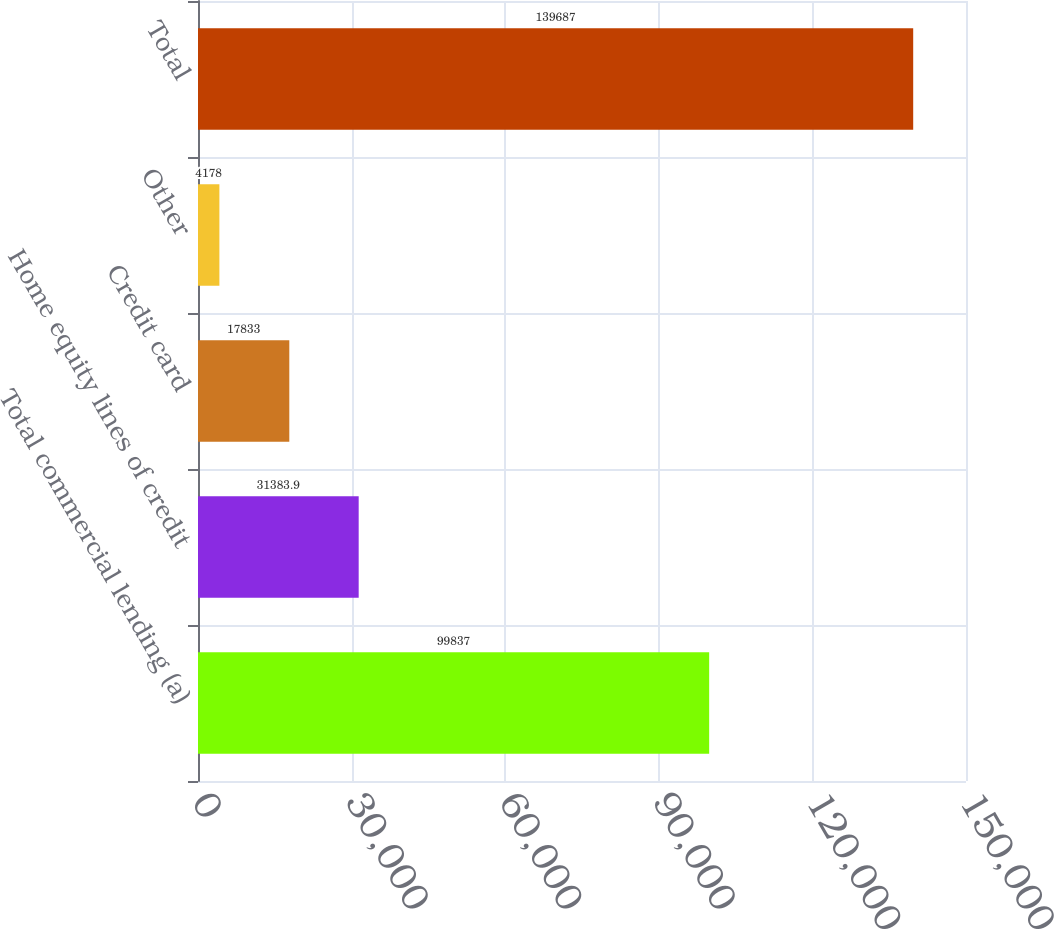Convert chart to OTSL. <chart><loc_0><loc_0><loc_500><loc_500><bar_chart><fcel>Total commercial lending (a)<fcel>Home equity lines of credit<fcel>Credit card<fcel>Other<fcel>Total<nl><fcel>99837<fcel>31383.9<fcel>17833<fcel>4178<fcel>139687<nl></chart> 